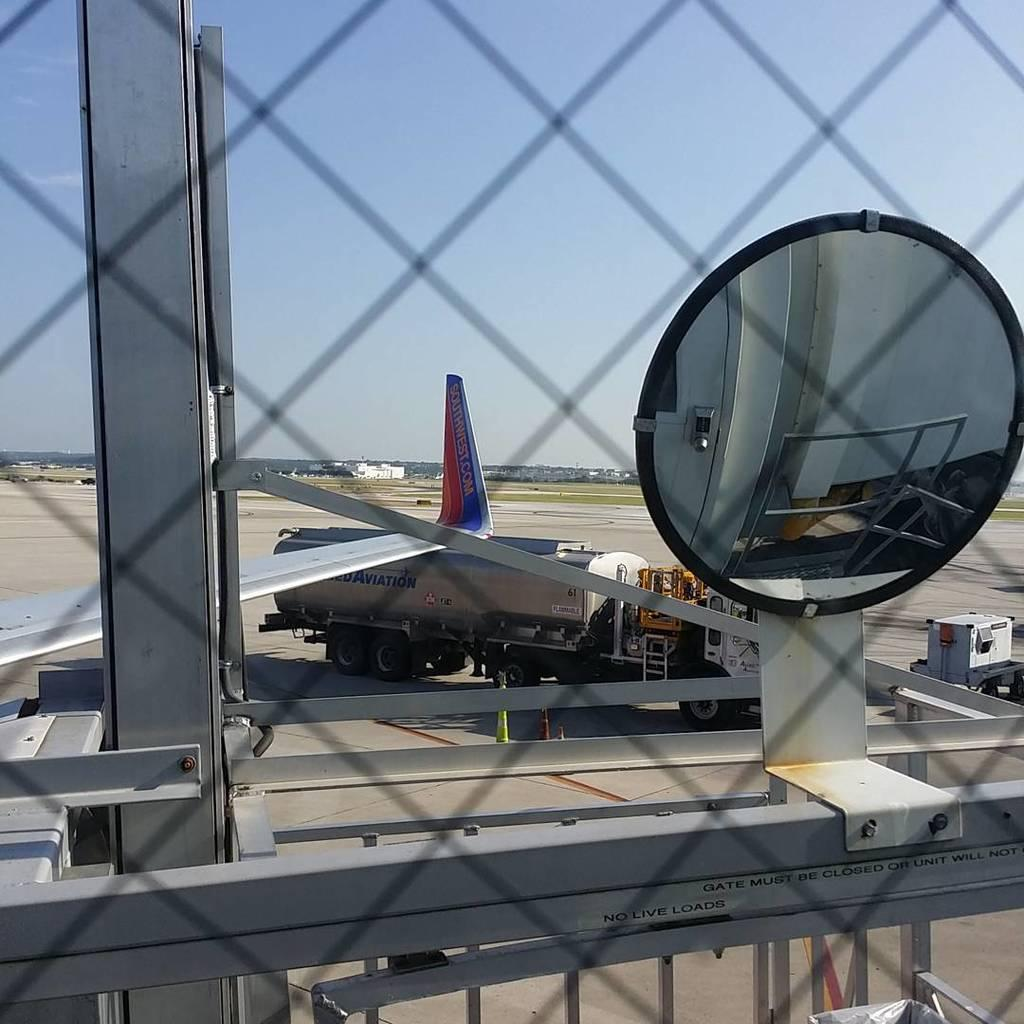<image>
Summarize the visual content of the image. The wing of a passenger plane displays the name Southwest.com on it. 